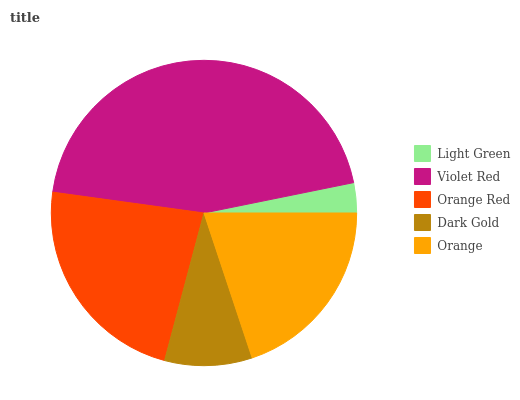Is Light Green the minimum?
Answer yes or no. Yes. Is Violet Red the maximum?
Answer yes or no. Yes. Is Orange Red the minimum?
Answer yes or no. No. Is Orange Red the maximum?
Answer yes or no. No. Is Violet Red greater than Orange Red?
Answer yes or no. Yes. Is Orange Red less than Violet Red?
Answer yes or no. Yes. Is Orange Red greater than Violet Red?
Answer yes or no. No. Is Violet Red less than Orange Red?
Answer yes or no. No. Is Orange the high median?
Answer yes or no. Yes. Is Orange the low median?
Answer yes or no. Yes. Is Violet Red the high median?
Answer yes or no. No. Is Light Green the low median?
Answer yes or no. No. 